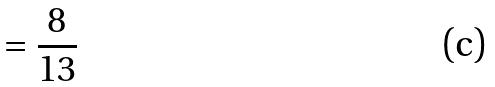<formula> <loc_0><loc_0><loc_500><loc_500>= \frac { 8 } { 1 3 }</formula> 